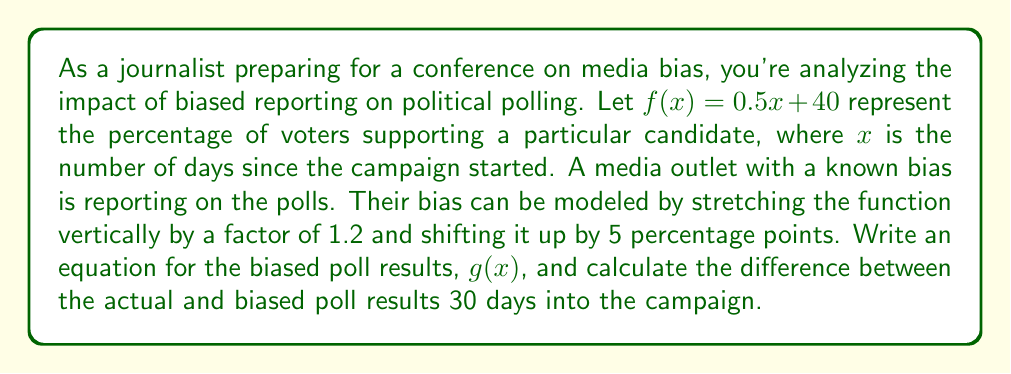What is the answer to this math problem? To solve this problem, we'll follow these steps:

1) First, let's recall the original function: $f(x) = 0.5x + 40$

2) The media bias involves two transformations:
   a) A vertical stretch by a factor of 1.2
   b) A vertical shift up by 5 percentage points

3) To apply a vertical stretch, we multiply the entire function by the stretch factor:
   $1.2(0.5x + 40)$

4) To apply a vertical shift up, we add the shift amount to the function:
   $1.2(0.5x + 40) + 5$

5) Therefore, the equation for the biased poll results, $g(x)$, is:
   $g(x) = 1.2(0.5x + 40) + 5$

6) Simplify this equation:
   $g(x) = 0.6x + 48 + 5 = 0.6x + 53$

7) To find the difference 30 days into the campaign:
   a) Calculate $f(30)$: 
      $f(30) = 0.5(30) + 40 = 15 + 40 = 55$
   b) Calculate $g(30)$:
      $g(30) = 0.6(30) + 53 = 18 + 53 = 71$
   c) Find the difference:
      $71 - 55 = 16$

Therefore, 30 days into the campaign, the biased poll results show a 16 percentage point increase compared to the actual poll results.
Answer: The equation for the biased poll results is $g(x) = 0.6x + 53$. The difference between the biased and actual poll results 30 days into the campaign is 16 percentage points. 